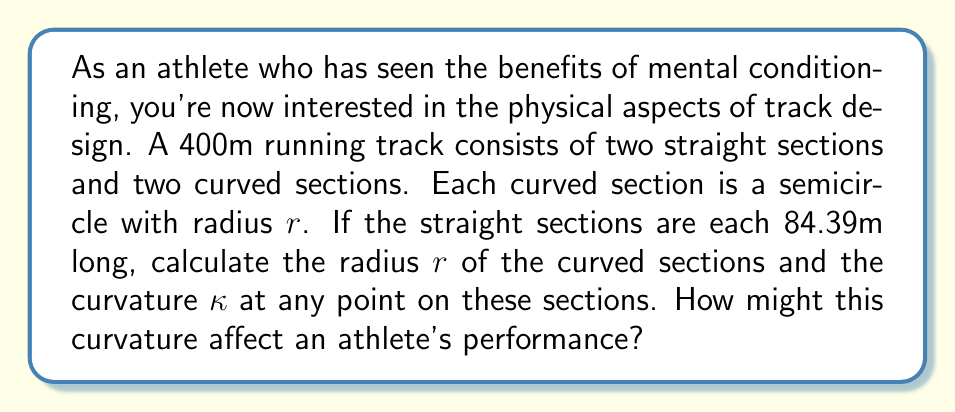Solve this math problem. Let's approach this step-by-step:

1) First, we need to find the radius $r$ of the curved sections. We know that:
   - The total length of the track is 400m
   - There are two straight sections, each 84.39m long
   - The curved sections are semicircles

2) Let's set up an equation:
   $$2 \cdot 84.39 + 2 \cdot \pi r = 400$$

3) Simplify:
   $$168.78 + 2\pi r = 400$$

4) Solve for $r$:
   $$2\pi r = 400 - 168.78 = 231.22$$
   $$r = \frac{231.22}{2\pi} \approx 36.80m$$

5) Now that we have the radius, we can calculate the curvature $\kappa$. For a circle, the curvature is the reciprocal of the radius:
   $$\kappa = \frac{1}{r} = \frac{1}{36.80} \approx 0.0272 \text{ m}^{-1}$$

6) Effect on athlete performance:
   The curvature affects an athlete's performance in several ways:
   - Centripetal force: Athletes must lean into the curve to counteract this force.
   - Stride adjustment: The inside leg travels a shorter distance than the outside leg.
   - Visual perception: The curve can affect an athlete's ability to judge distance and position.
   - Energy expenditure: Running on a curve requires more energy than running straight.

[asy]
import geometry;

size(200);
pair O = (0,0);
real r = 36.8;
draw(circle(O,r), blue);
draw((-r,0)--(r,0), red);
label("r", (r/2,r/2), NE);
label("Curved section", (0,r), N);
label("Straight section", (r,0), E);
[/asy]
Answer: The radius of the curved sections is approximately 36.80m, and the curvature is approximately 0.0272 m^-1. This curvature affects athlete performance through centripetal force, stride adjustments, visual perception changes, and increased energy expenditure. 